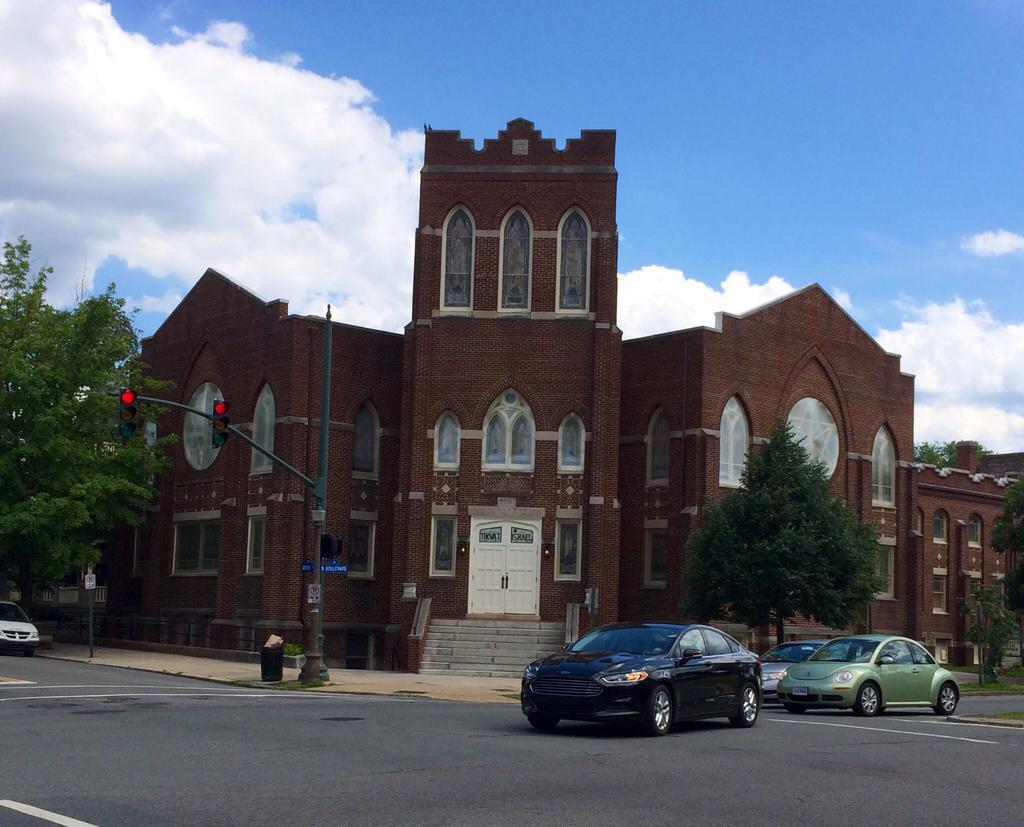Please provide a concise description of this image. In the picture I can see a building which has few glass windows on it and there is a staircase in front of it and there are few trees on either sides of the building and there are few vehicles on the road. 